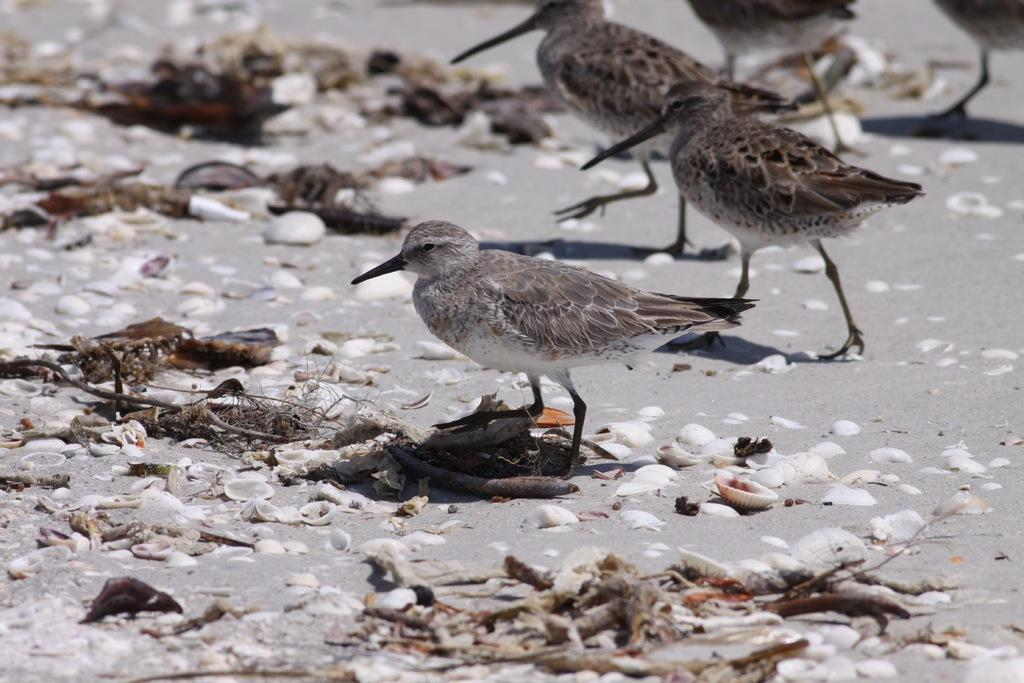What type of animals can be seen in the image? There are birds in the image. What other objects can be seen in the image besides the birds? There are shells in the image. What type of rat can be seen in the image? There is no rat present in the image. What type of seed is being consumed by the birds in the image? There is no seed visible in the image, and the birds' diet is not mentioned in the provided facts. 